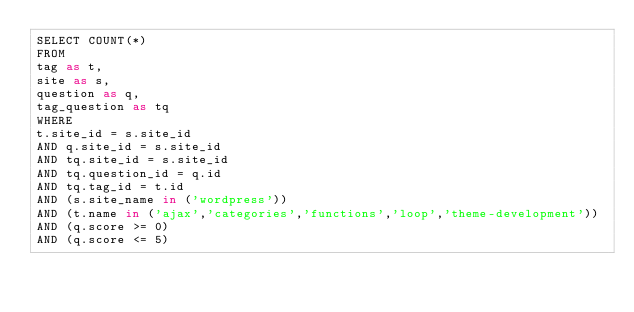<code> <loc_0><loc_0><loc_500><loc_500><_SQL_>SELECT COUNT(*)
FROM
tag as t,
site as s,
question as q,
tag_question as tq
WHERE
t.site_id = s.site_id
AND q.site_id = s.site_id
AND tq.site_id = s.site_id
AND tq.question_id = q.id
AND tq.tag_id = t.id
AND (s.site_name in ('wordpress'))
AND (t.name in ('ajax','categories','functions','loop','theme-development'))
AND (q.score >= 0)
AND (q.score <= 5)
</code> 